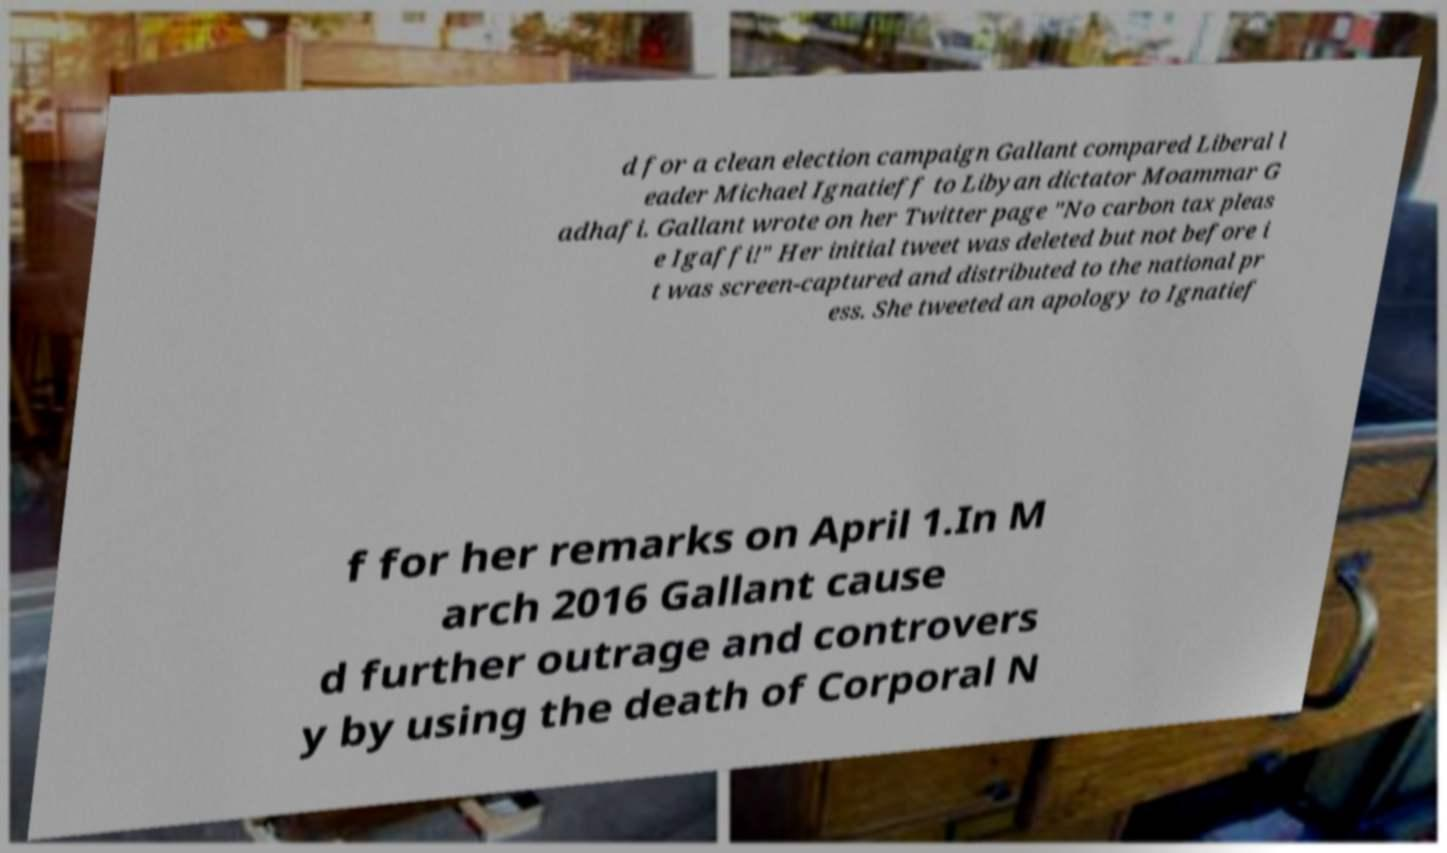Could you assist in decoding the text presented in this image and type it out clearly? d for a clean election campaign Gallant compared Liberal l eader Michael Ignatieff to Libyan dictator Moammar G adhafi. Gallant wrote on her Twitter page "No carbon tax pleas e Igaffi!" Her initial tweet was deleted but not before i t was screen-captured and distributed to the national pr ess. She tweeted an apology to Ignatief f for her remarks on April 1.In M arch 2016 Gallant cause d further outrage and controvers y by using the death of Corporal N 